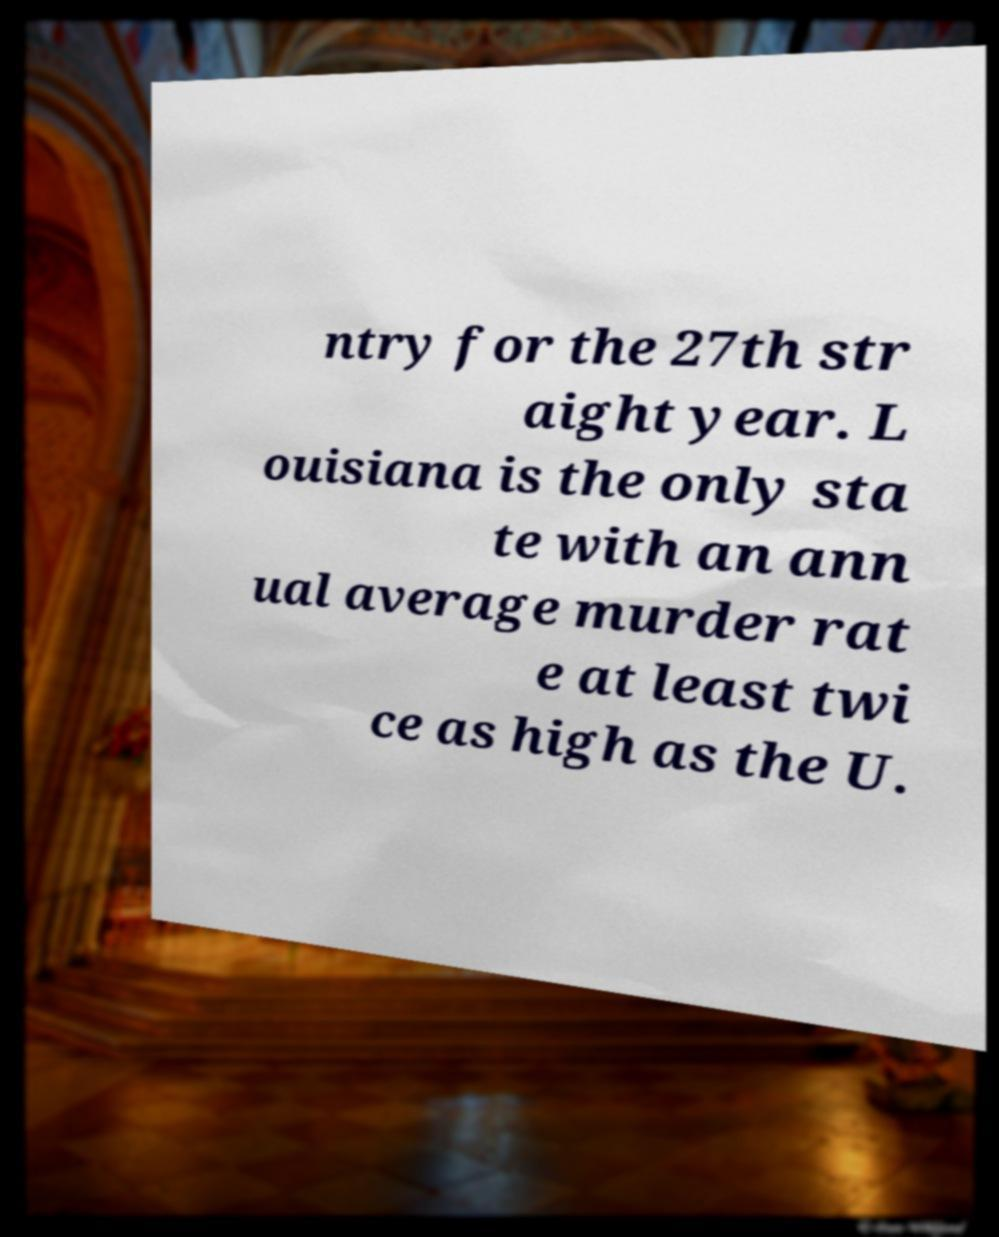Please identify and transcribe the text found in this image. ntry for the 27th str aight year. L ouisiana is the only sta te with an ann ual average murder rat e at least twi ce as high as the U. 